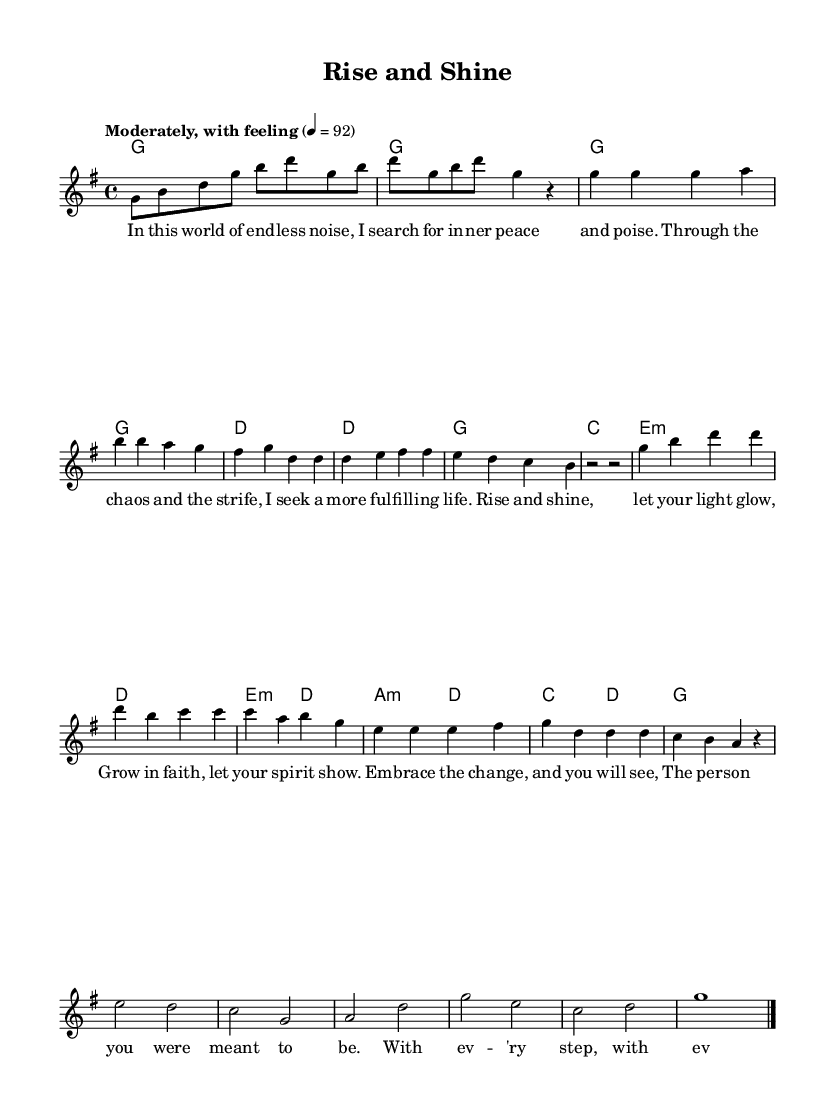What is the key signature of this music? The key signature is G major, which has one sharp (F#). This can be identified by looking at the key signature indicated at the beginning of the staff.
Answer: G major What is the time signature of this music? The time signature is four-four, indicated by the "4/4" notation at the beginning of the score. This means there are four beats in each measure and a quarter note receives one beat.
Answer: Four-four What is the tempo marking of this piece? The tempo marking is "Moderately, with feeling," which gives performers a sense of how to express the music. Additionally, it indicates a beats per minute (BPM) of 92, found in the tempo designation at the start of the piece.
Answer: Moderately, with feeling What are the first two chords in the harmonic structure? The first two chords in the harmonic structure are G major and G major, as indicated in the harmony section of the score. Both chords appear at the beginning of the piece, confirming their function at the start of the music.
Answer: G major, G major How many measures are in the chorus section? The chorus section consists of six measures. By counting the measures indicated by the divisions in the staff, you can account for each measure in the chorus.
Answer: Six measures What lyrical theme is presented in the bridge? The lyrical theme in the bridge revolves around personal growth and gaining wisdom with each step of life. This is inferred from the lyrics provided, which describe a journey of discovering wisdom throughout daily life.
Answer: Personal growth and wisdom Which musical section contains the term "Embrace the change"? The phrase "Embrace the change" is found in the chorus section of the lyrics, indicating a theme of acceptance and personal transformation. This can be verified by locating the corresponding lyrics in the chorus lines provided.
Answer: Chorus 